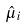Convert formula to latex. <formula><loc_0><loc_0><loc_500><loc_500>\hat { \mu } _ { i }</formula> 